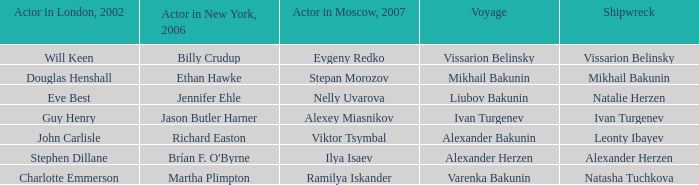Who was the actor in Moscow who did the part done by John Carlisle in London in 2002? Viktor Tsymbal. 